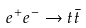<formula> <loc_0><loc_0><loc_500><loc_500>e ^ { + } e ^ { - } \rightarrow t \bar { t }</formula> 